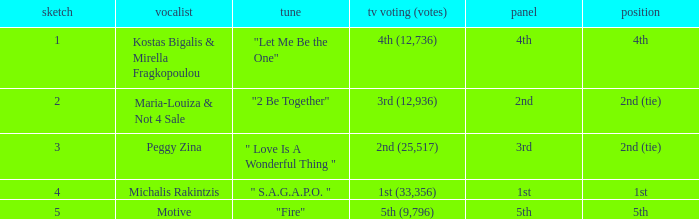What song was 2nd (25,517) in televoting (votes)? " Love Is A Wonderful Thing ". 